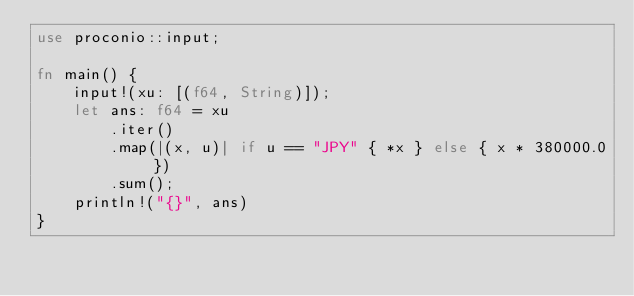Convert code to text. <code><loc_0><loc_0><loc_500><loc_500><_Rust_>use proconio::input;

fn main() {
    input!(xu: [(f64, String)]);
    let ans: f64 = xu
        .iter()
        .map(|(x, u)| if u == "JPY" { *x } else { x * 380000.0 })
        .sum();
    println!("{}", ans)
}
</code> 